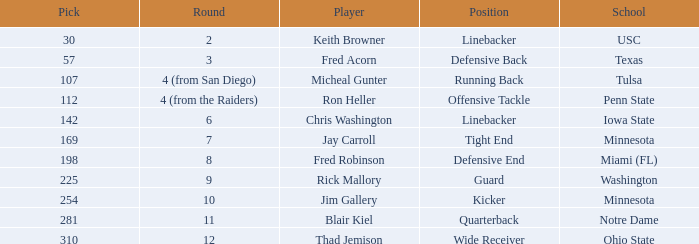What is Thad Jemison's position? Wide Receiver. 